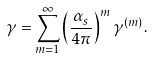<formula> <loc_0><loc_0><loc_500><loc_500>\gamma = \sum _ { m = 1 } ^ { \infty } \left ( \frac { \alpha _ { s } } { 4 \pi } \right ) ^ { m } \gamma ^ { ( m ) } .</formula> 